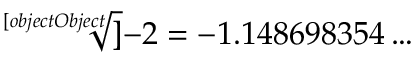Convert formula to latex. <formula><loc_0><loc_0><loc_500><loc_500>{ \sqrt { [ } [ o b j e c t O b j e c t ] ] { - 2 } } = - 1 . 1 4 8 6 9 8 3 5 4 \dots</formula> 